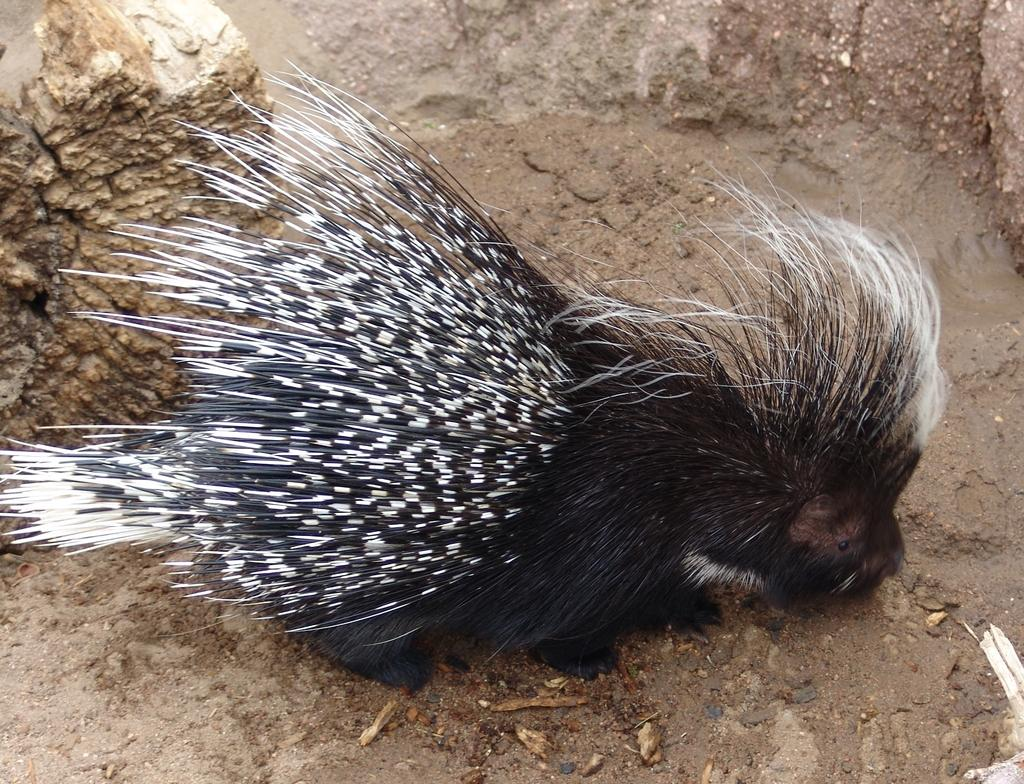What type of animal can be seen in the image? There is a bird in the image. What colors are present on the bird? The bird is black and brown in color. Where is the bird located in the image? The bird is on the ground. What other object can be seen in the image? There is a rock visible in the image. Who is the expert in the bird's plantation in the image? There is no reference to an expert or a plantation in the image; it simply features a bird on the ground and a rock. 